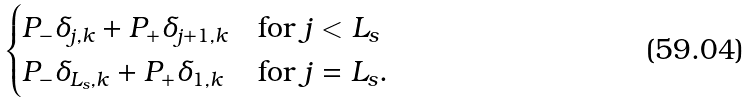Convert formula to latex. <formula><loc_0><loc_0><loc_500><loc_500>\begin{cases} P _ { - } \delta _ { j , k } + P _ { + } \delta _ { j + 1 , k } & \text {for $j < L_{s}$} \\ P _ { - } \delta _ { L _ { s } , k } + P _ { + } \delta _ { 1 , k } & \text {for $j = L_{s}$} . \end{cases}</formula> 